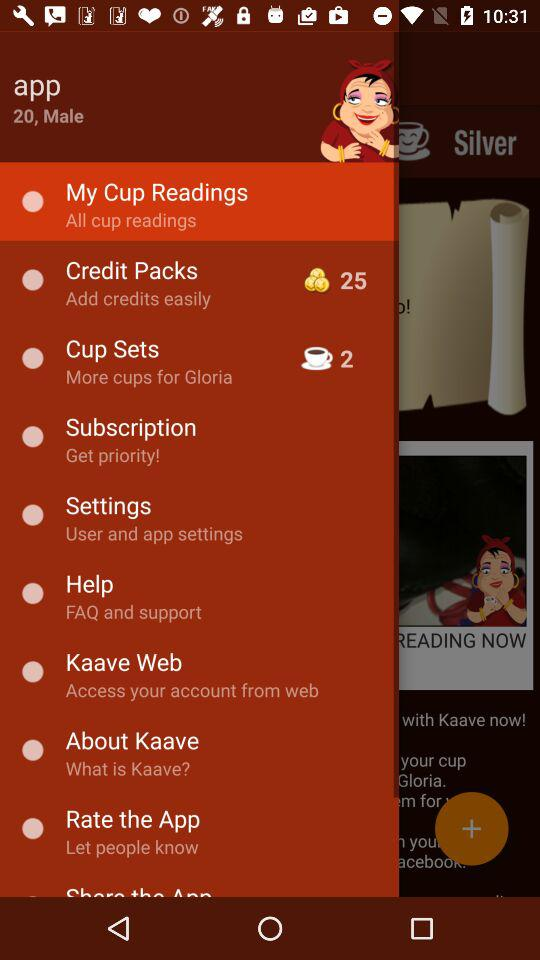What is the user name? The user name is App. 